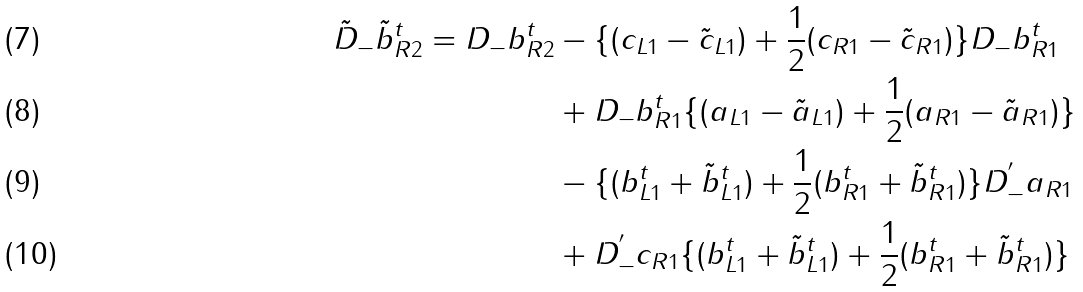<formula> <loc_0><loc_0><loc_500><loc_500>\tilde { D } _ { - } \tilde { b } _ { R 2 } ^ { t } = D _ { - } b _ { R 2 } ^ { t } & - \{ ( c _ { L 1 } - \tilde { c } _ { L 1 } ) + \frac { 1 } { 2 } ( c _ { R 1 } - \tilde { c } _ { R 1 } ) \} D _ { - } b _ { R 1 } ^ { t } \\ & + D _ { - } b _ { R 1 } ^ { t } \{ ( a _ { L 1 } - \tilde { a } _ { L 1 } ) + \frac { 1 } { 2 } ( a _ { R 1 } - \tilde { a } _ { R 1 } ) \} \\ & - \{ ( b _ { L 1 } ^ { t } + \tilde { b } _ { L 1 } ^ { t } ) + \frac { 1 } { 2 } ( b _ { R 1 } ^ { t } + \tilde { b } _ { R 1 } ^ { t } ) \} D _ { - } ^ { ^ { \prime } } a _ { R 1 } \\ & + D _ { - } ^ { ^ { \prime } } c _ { R 1 } \{ ( b _ { L 1 } ^ { t } + \tilde { b } _ { L 1 } ^ { t } ) + \frac { 1 } { 2 } ( b _ { R 1 } ^ { t } + \tilde { b } _ { R 1 } ^ { t } ) \}</formula> 